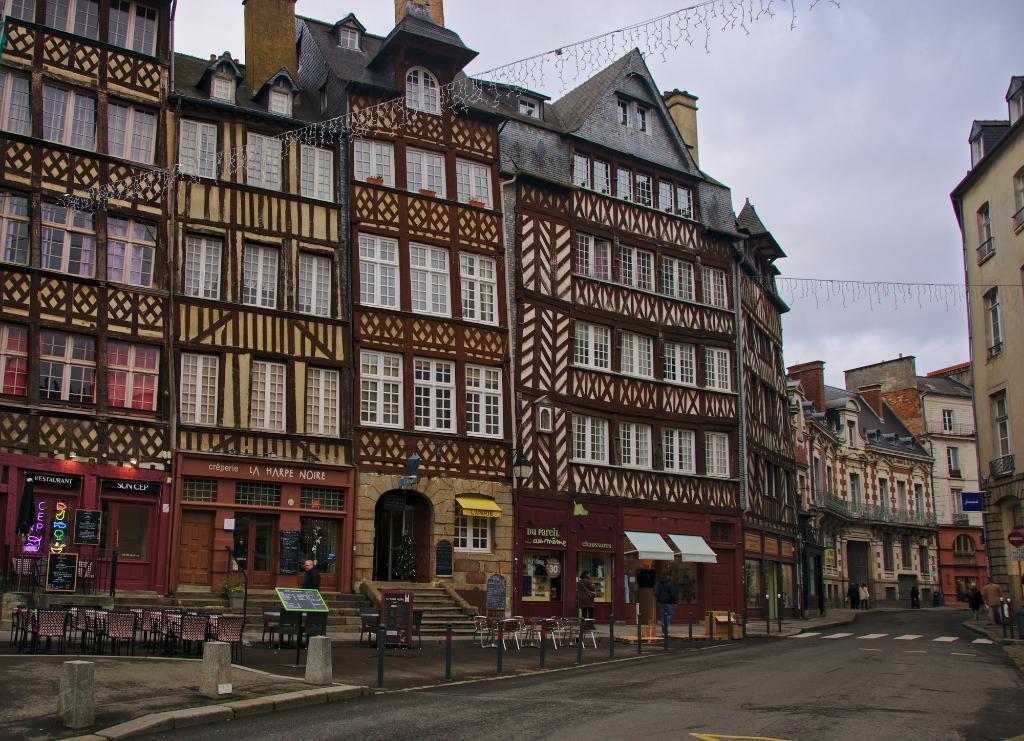What type of structures can be seen in the image? There are buildings in the image. What is located at the bottom of the image? There is a road at the bottom of the image. What type of furniture or seating is visible in the image? Chairs and stands are visible in the image. Can you describe the road in the image? The road is visible in the image. What can be seen in the background of the image? There is visible in the background of the image. How many guides are present in the image? There is no mention of guides in the image, so it is impossible to determine their presence or quantity. What type of porter can be seen carrying items in the image? There is no porter present in the image, carrying items or otherwise. 